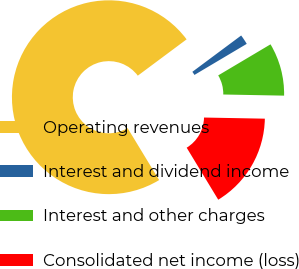Convert chart. <chart><loc_0><loc_0><loc_500><loc_500><pie_chart><fcel>Operating revenues<fcel>Interest and dividend income<fcel>Interest and other charges<fcel>Consolidated net income (loss)<nl><fcel>73.5%<fcel>1.65%<fcel>8.83%<fcel>16.02%<nl></chart> 